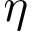Convert formula to latex. <formula><loc_0><loc_0><loc_500><loc_500>\eta</formula> 